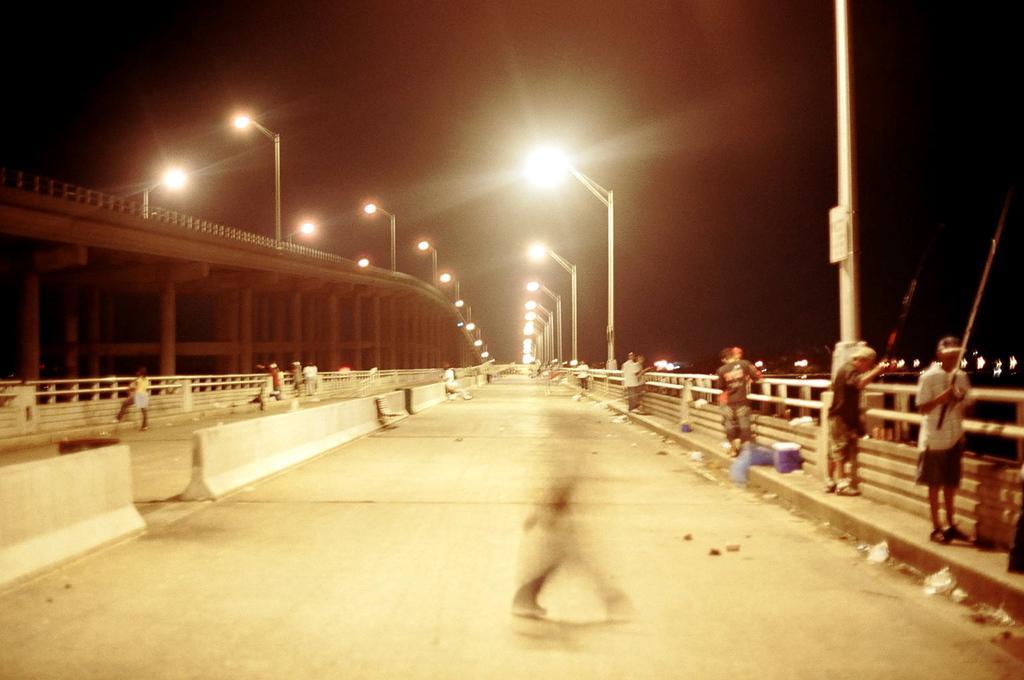In one or two sentences, can you explain what this image depicts? In the center of the image there is a bridge. On the right there are people standing. In the background there are poles, lights and sky. 